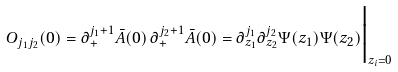<formula> <loc_0><loc_0><loc_500><loc_500>O _ { j _ { 1 } j _ { 2 } } ( 0 ) = \partial _ { + } ^ { j _ { 1 } + 1 } \bar { A } ( 0 ) \, \partial _ { + } ^ { j _ { 2 } + 1 } \bar { A } ( 0 ) = \partial _ { z _ { 1 } } ^ { j _ { 1 } } \partial _ { z _ { 2 } } ^ { j _ { 2 } } { \Psi } ( z _ { 1 } ) { \Psi } ( z _ { 2 } ) \Big | _ { z _ { i } = 0 }</formula> 